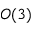<formula> <loc_0><loc_0><loc_500><loc_500>O ( 3 )</formula> 